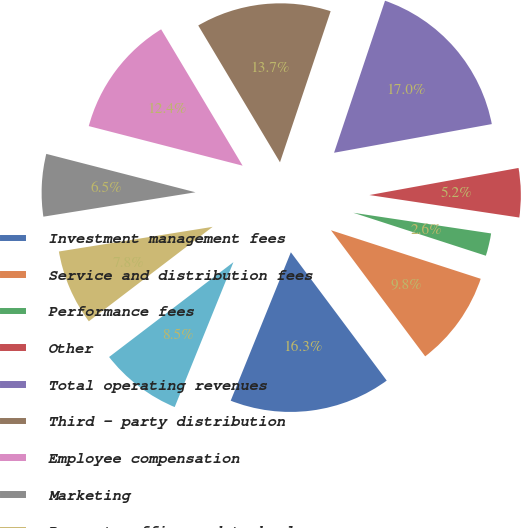<chart> <loc_0><loc_0><loc_500><loc_500><pie_chart><fcel>Investment management fees<fcel>Service and distribution fees<fcel>Performance fees<fcel>Other<fcel>Total operating revenues<fcel>Third - party distribution<fcel>Employee compensation<fcel>Marketing<fcel>Property office and technology<fcel>General and administrative<nl><fcel>16.34%<fcel>9.8%<fcel>2.62%<fcel>5.23%<fcel>16.99%<fcel>13.72%<fcel>12.42%<fcel>6.54%<fcel>7.84%<fcel>8.5%<nl></chart> 